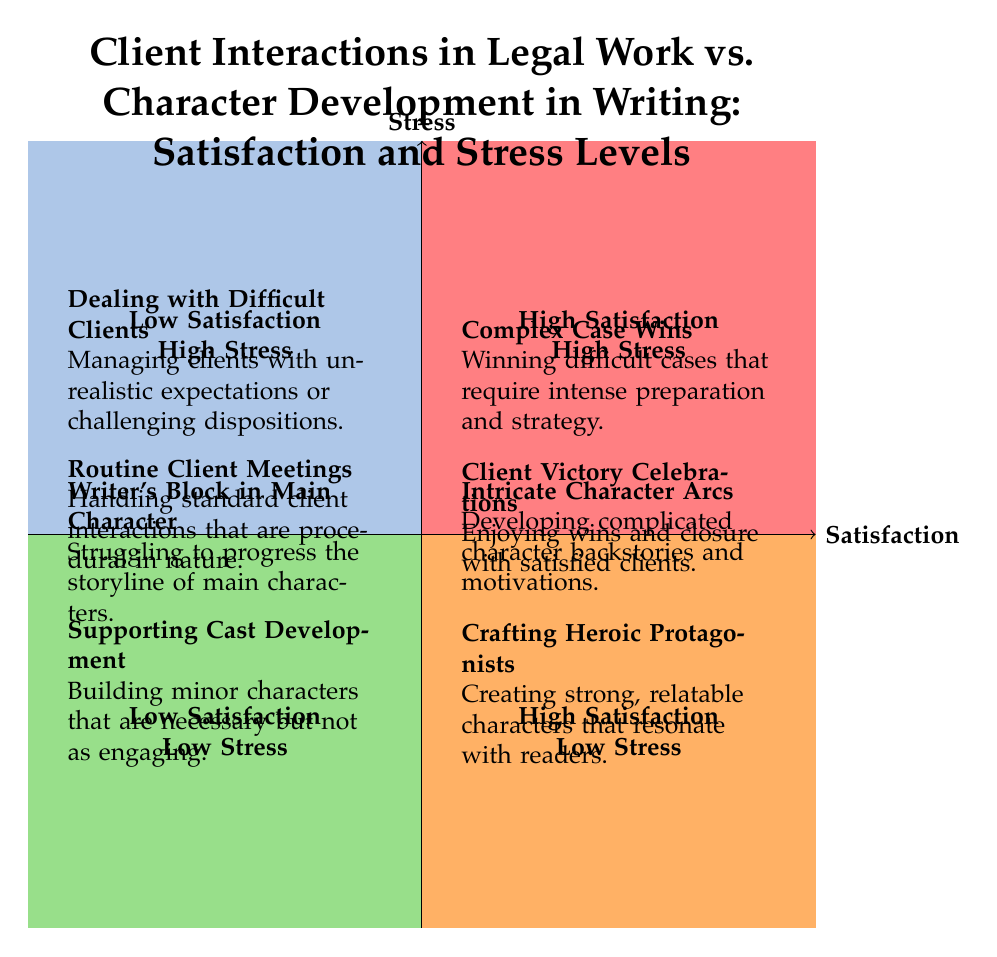What are the two activities in the "High Satisfaction - Low Stress" quadrant? In the "High Satisfaction - Low Stress" quadrant, there are two activities listed: "Client Victory Celebrations" and "Crafting Heroic Protagonists". These are the only two items in that specific section, which indicates that they share the traits of high satisfaction and low stress.
Answer: Client Victory Celebrations, Crafting Heroic Protagonists How many activities are there in total across all quadrants? By counting the items listed in each of the four quadrants, we see 2 activities in the first quadrant, 2 in the second, 2 in the third, and 2 in the fourth, leading to a total of 8 activities.
Answer: 8 Which activity in the "Low Satisfaction - High Stress" quadrant involves managing client relationships? The activity from the "Low Satisfaction - High Stress" quadrant that involves managing client relationships is "Dealing with Difficult Clients". This highlights a stressful situation in client interactions while reducing overall satisfaction.
Answer: Dealing with Difficult Clients What is the relationship between "Complex Case Wins" and "Intricate Character Arcs"? Both "Complex Case Wins" and "Intricate Character Arcs" are located in the "High Satisfaction - High Stress" quadrant, indicating that they share similar characteristics of providing high satisfaction despite also being high-stress activities. This relationship suggests that both involve a significant degree of skill and effort.
Answer: High Satisfaction - High Stress Which activity has the lowest satisfaction level in legal work? The activity with the lowest satisfaction level in legal work is "Dealing with Difficult Clients" as it is positioned in the "Low Satisfaction - High Stress" quadrant, highlighting the stressors associated with that client interaction.
Answer: Dealing with Difficult Clients What can be inferred about routine client meetings? Routine client meetings are placed in the "Low Satisfaction - Low Stress" quadrant, suggesting they are standard interactions that result in low emotional engagement and less stress, implying they are routine and unchallenging.
Answer: Low Satisfaction - Low Stress How does "Writer’s Block in Main Character" relate to stress levels? "Writer’s Block in Main Character" is positioned in the "Low Satisfaction - High Stress" quadrant, indicating that this activity causes high levels of stress due to the creative struggle, while simultaneously resulting in low satisfaction and progress.
Answer: Low Satisfaction - High Stress Which quadrant contains activities that showcase high satisfaction but also high levels of stress? The "High Satisfaction - High Stress" quadrant contains the activities "Complex Case Wins" and "Intricate Character Arcs". They represent situations that lead to satisfaction through achievement but also demand high effort and cause stress.
Answer: High Satisfaction - High Stress 